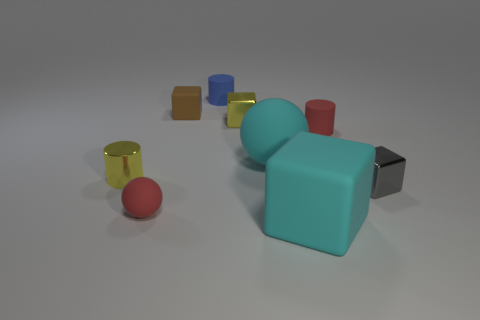Is the color of the small ball the same as the tiny matte cylinder in front of the tiny brown block?
Give a very brief answer. Yes. Is there a sphere of the same color as the big rubber block?
Your answer should be compact. Yes. Do the tiny gray thing and the sphere behind the tiny yellow shiny cylinder have the same material?
Make the answer very short. No. What material is the big cyan block?
Keep it short and to the point. Rubber. There is a cylinder that is the same color as the small matte ball; what is it made of?
Provide a short and direct response. Rubber. How many other objects are there of the same material as the red cylinder?
Give a very brief answer. 5. The matte object that is both right of the big cyan sphere and left of the small red matte cylinder has what shape?
Give a very brief answer. Cube. What color is the tiny ball that is made of the same material as the tiny red cylinder?
Provide a short and direct response. Red. Are there an equal number of brown rubber objects to the right of the big matte block and big yellow rubber spheres?
Provide a short and direct response. Yes. What shape is the blue matte thing that is the same size as the brown matte thing?
Your response must be concise. Cylinder. 